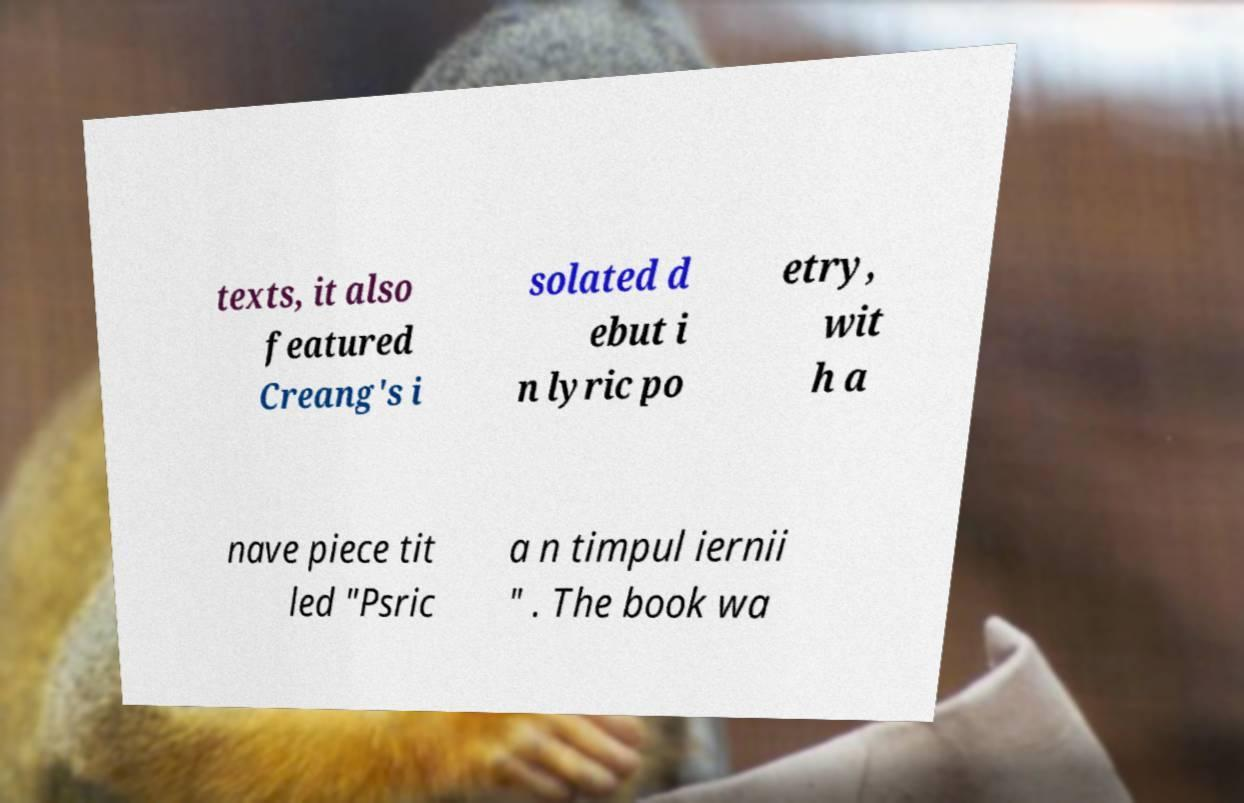Could you extract and type out the text from this image? texts, it also featured Creang's i solated d ebut i n lyric po etry, wit h a nave piece tit led "Psric a n timpul iernii " . The book wa 